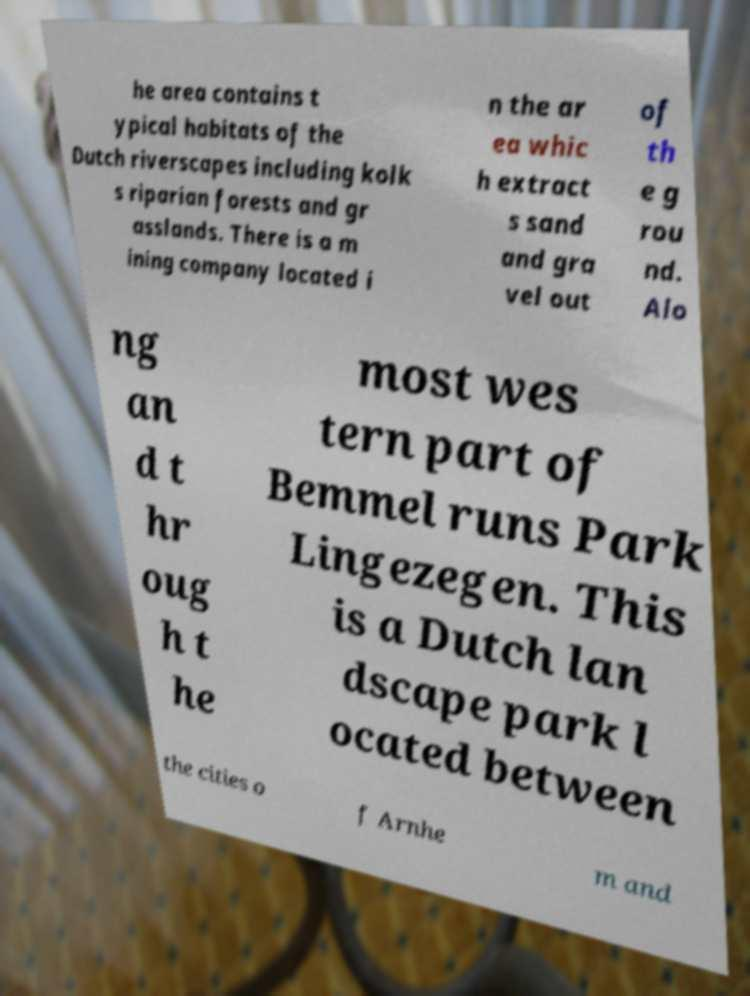Could you extract and type out the text from this image? he area contains t ypical habitats of the Dutch riverscapes including kolk s riparian forests and gr asslands. There is a m ining company located i n the ar ea whic h extract s sand and gra vel out of th e g rou nd. Alo ng an d t hr oug h t he most wes tern part of Bemmel runs Park Lingezegen. This is a Dutch lan dscape park l ocated between the cities o f Arnhe m and 